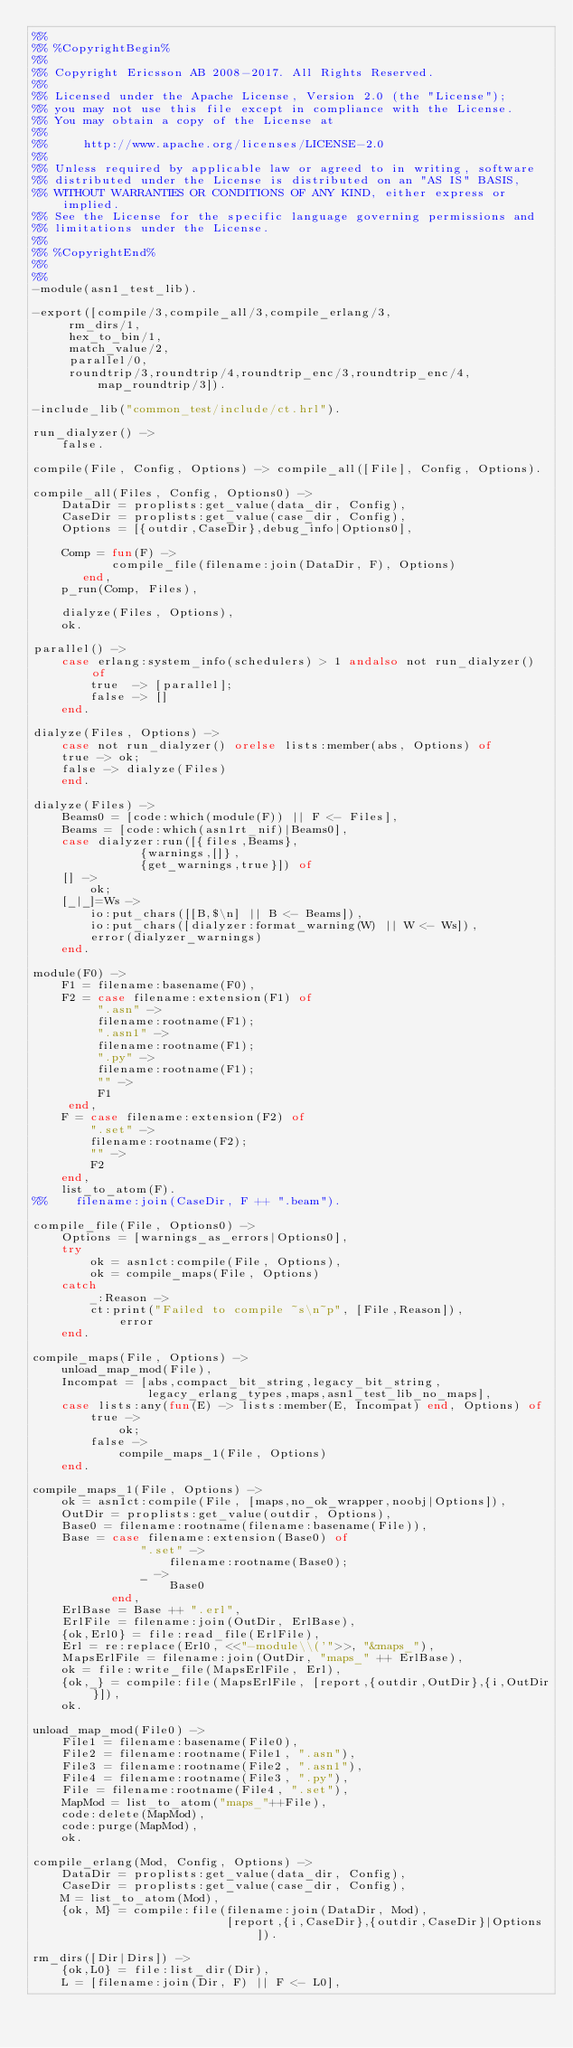<code> <loc_0><loc_0><loc_500><loc_500><_Erlang_>%%
%% %CopyrightBegin%
%%
%% Copyright Ericsson AB 2008-2017. All Rights Reserved.
%%
%% Licensed under the Apache License, Version 2.0 (the "License");
%% you may not use this file except in compliance with the License.
%% You may obtain a copy of the License at
%%
%%     http://www.apache.org/licenses/LICENSE-2.0
%%
%% Unless required by applicable law or agreed to in writing, software
%% distributed under the License is distributed on an "AS IS" BASIS,
%% WITHOUT WARRANTIES OR CONDITIONS OF ANY KIND, either express or implied.
%% See the License for the specific language governing permissions and
%% limitations under the License.
%%
%% %CopyrightEnd%
%%
%%
-module(asn1_test_lib).

-export([compile/3,compile_all/3,compile_erlang/3,
	 rm_dirs/1,
	 hex_to_bin/1,
	 match_value/2,
	 parallel/0,
	 roundtrip/3,roundtrip/4,roundtrip_enc/3,roundtrip_enc/4,
         map_roundtrip/3]).

-include_lib("common_test/include/ct.hrl").

run_dialyzer() ->
    false.

compile(File, Config, Options) -> compile_all([File], Config, Options).

compile_all(Files, Config, Options0) ->
    DataDir = proplists:get_value(data_dir, Config),
    CaseDir = proplists:get_value(case_dir, Config),
    Options = [{outdir,CaseDir},debug_info|Options0],

    Comp = fun(F) ->
		   compile_file(filename:join(DataDir, F), Options)
	   end,
    p_run(Comp, Files),

    dialyze(Files, Options),
    ok.

parallel() ->
    case erlang:system_info(schedulers) > 1 andalso not run_dialyzer() of
        true  -> [parallel];
        false -> []
    end.

dialyze(Files, Options) ->
    case not run_dialyzer() orelse lists:member(abs, Options) of
	true -> ok;
	false -> dialyze(Files)
    end.

dialyze(Files) ->
    Beams0 = [code:which(module(F)) || F <- Files],
    Beams = [code:which(asn1rt_nif)|Beams0],
    case dialyzer:run([{files,Beams},
		       {warnings,[]},
		       {get_warnings,true}]) of
	[] ->
	    ok;
	[_|_]=Ws ->
	    io:put_chars([[B,$\n] || B <- Beams]),
	    io:put_chars([dialyzer:format_warning(W) || W <- Ws]),
	    error(dialyzer_warnings)
    end.

module(F0) ->
    F1 = filename:basename(F0),
    F2 = case filename:extension(F1) of
	     ".asn" ->
		 filename:rootname(F1);
	     ".asn1" ->
		 filename:rootname(F1);
	     ".py" ->
		 filename:rootname(F1);
	     "" ->
		 F1
	 end,
    F = case filename:extension(F2) of
	    ".set" ->
		filename:rootname(F2);
	    "" ->
		F2
	end,
    list_to_atom(F).
%%    filename:join(CaseDir, F ++ ".beam").

compile_file(File, Options0) ->
    Options = [warnings_as_errors|Options0],
    try
        ok = asn1ct:compile(File, Options),
        ok = compile_maps(File, Options)
    catch
        _:Reason ->
	    ct:print("Failed to compile ~s\n~p", [File,Reason]),
            error
    end.

compile_maps(File, Options) ->
    unload_map_mod(File),
    Incompat = [abs,compact_bit_string,legacy_bit_string,
                legacy_erlang_types,maps,asn1_test_lib_no_maps],
    case lists:any(fun(E) -> lists:member(E, Incompat) end, Options) of
        true ->
            ok;
        false ->
            compile_maps_1(File, Options)
    end.

compile_maps_1(File, Options) ->
    ok = asn1ct:compile(File, [maps,no_ok_wrapper,noobj|Options]),
    OutDir = proplists:get_value(outdir, Options),
    Base0 = filename:rootname(filename:basename(File)),
    Base = case filename:extension(Base0) of
               ".set" ->
                   filename:rootname(Base0);
               _ ->
                   Base0
           end,
    ErlBase = Base ++ ".erl",
    ErlFile = filename:join(OutDir, ErlBase),
    {ok,Erl0} = file:read_file(ErlFile),
    Erl = re:replace(Erl0, <<"-module\\('">>, "&maps_"),
    MapsErlFile = filename:join(OutDir, "maps_" ++ ErlBase),
    ok = file:write_file(MapsErlFile, Erl),
    {ok,_} = compile:file(MapsErlFile, [report,{outdir,OutDir},{i,OutDir}]),
    ok.

unload_map_mod(File0) ->
    File1 = filename:basename(File0),
    File2 = filename:rootname(File1, ".asn"),
    File3 = filename:rootname(File2, ".asn1"),
    File4 = filename:rootname(File3, ".py"),
    File = filename:rootname(File4, ".set"),
    MapMod = list_to_atom("maps_"++File),
    code:delete(MapMod),
    code:purge(MapMod),
    ok.

compile_erlang(Mod, Config, Options) ->
    DataDir = proplists:get_value(data_dir, Config),
    CaseDir = proplists:get_value(case_dir, Config),
    M = list_to_atom(Mod),
    {ok, M} = compile:file(filename:join(DataDir, Mod),
                           [report,{i,CaseDir},{outdir,CaseDir}|Options]).

rm_dirs([Dir|Dirs]) ->
    {ok,L0} = file:list_dir(Dir),
    L = [filename:join(Dir, F) || F <- L0],</code> 